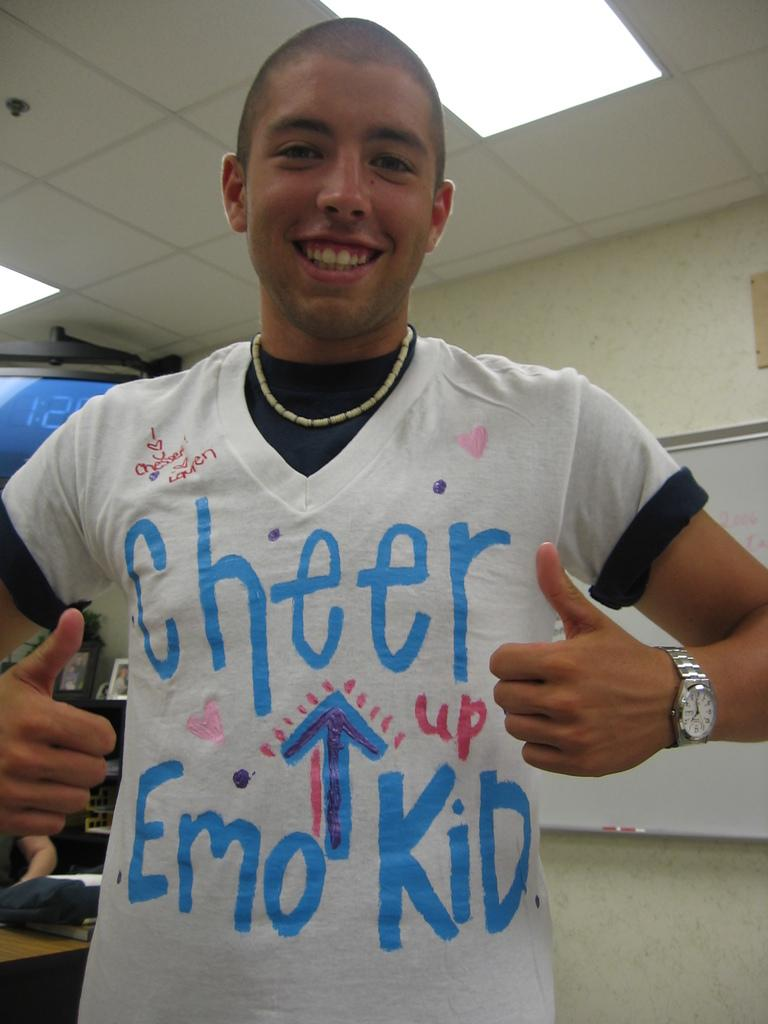<image>
Share a concise interpretation of the image provided. A boy wearing a white tshirt with the words cheer up emo kid on his chest. 